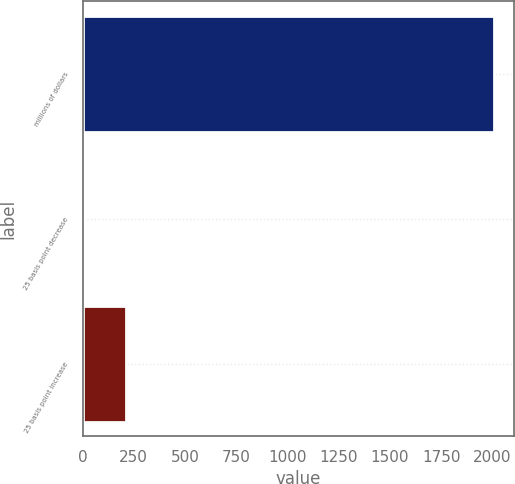Convert chart. <chart><loc_0><loc_0><loc_500><loc_500><bar_chart><fcel>millions of dollars<fcel>25 basis point decrease<fcel>25 basis point increase<nl><fcel>2007<fcel>13.3<fcel>212.67<nl></chart> 